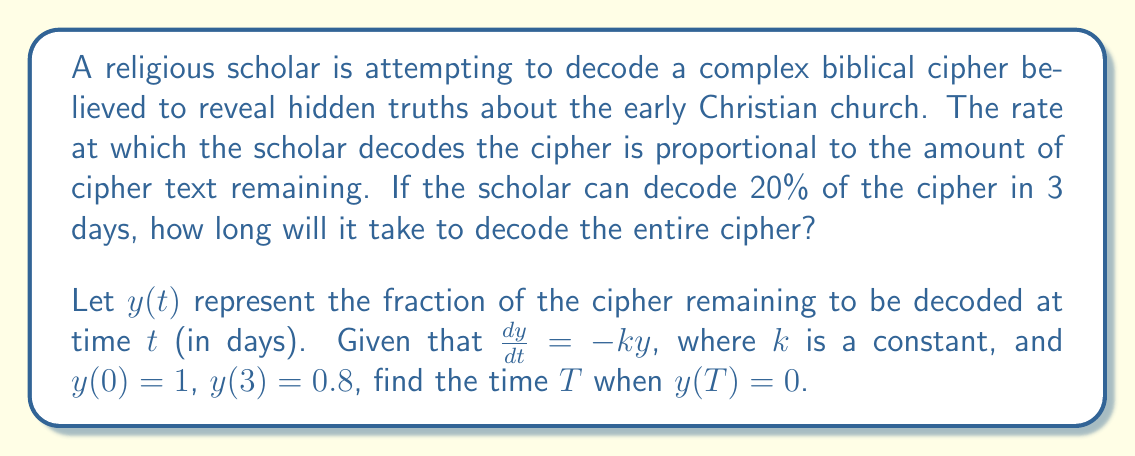Solve this math problem. To solve this problem, we'll use the first-order differential equation given:

1) We have $\frac{dy}{dt} = -ky$, which is a separable equation.

2) Separating variables: $\frac{dy}{y} = -k dt$

3) Integrating both sides: $\int \frac{dy}{y} = -k \int dt$

4) This gives us: $\ln|y| = -kt + C$, where $C$ is a constant of integration.

5) Solving for $y$: $y = e^{-kt + C} = Ae^{-kt}$, where $A = e^C$

6) Using the initial condition $y(0) = 1$:
   $1 = Ae^{-k(0)} = A$
   So, $y = e^{-kt}$

7) Now, using the condition $y(3) = 0.8$:
   $0.8 = e^{-k(3)}$
   $\ln(0.8) = -3k$
   $k = -\frac{\ln(0.8)}{3} \approx 0.0744$

8) To find when the entire cipher is decoded, we need to solve $y(T) = 0$:
   $0 = e^{-kT}$

9) However, this equation has no finite solution. As $t$ approaches infinity, $y$ approaches 0 asymptotically.

10) Instead, we can find the time when 99.9% of the cipher is decoded:
    $0.001 = e^{-kT}$
    $\ln(0.001) = -kT$
    $T = -\frac{\ln(0.001)}{k} \approx 93.43$ days
Answer: It will take approximately 93.43 days to decode 99.9% of the cipher. 